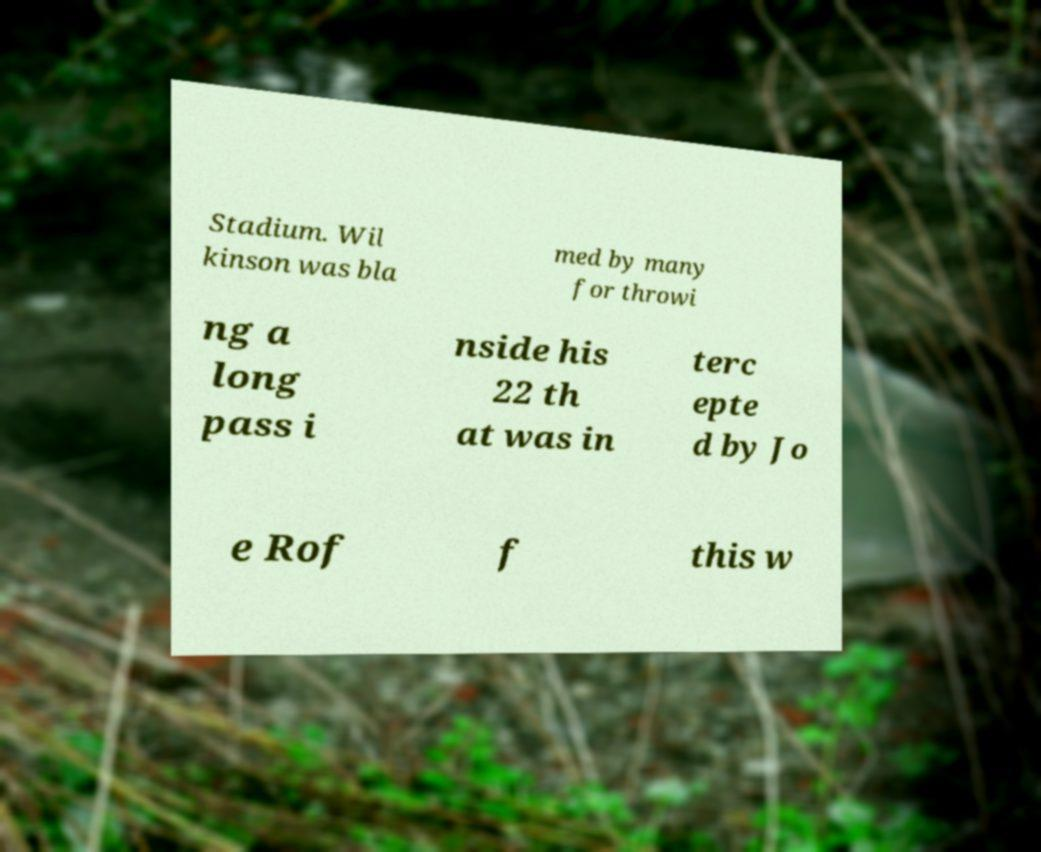Could you extract and type out the text from this image? Stadium. Wil kinson was bla med by many for throwi ng a long pass i nside his 22 th at was in terc epte d by Jo e Rof f this w 